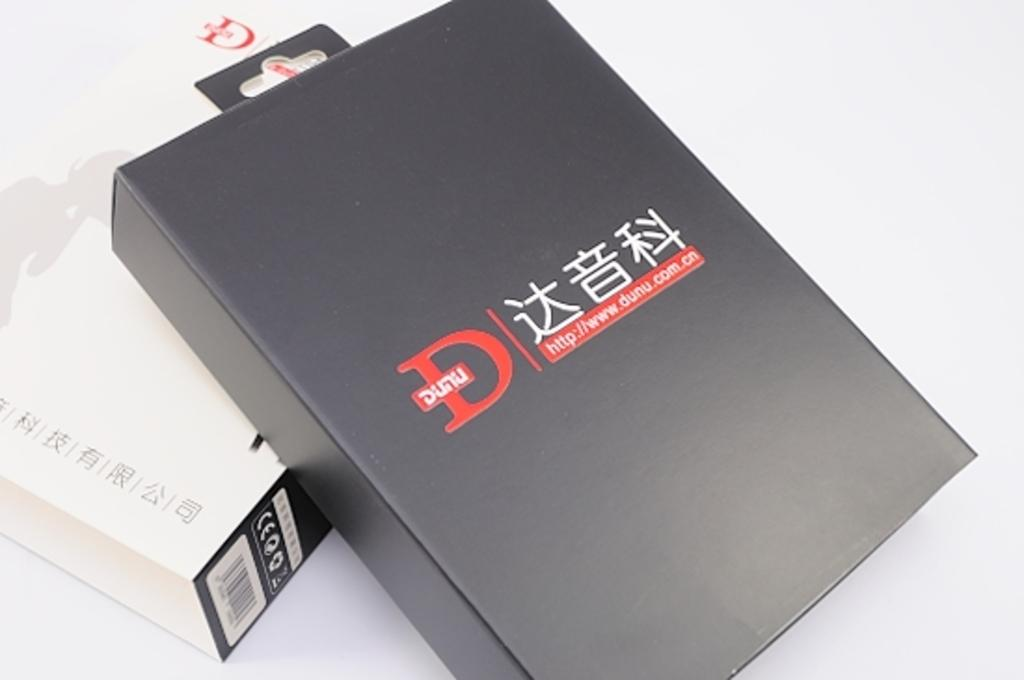<image>
Present a compact description of the photo's key features. A black box has a large letter D on it in red text. 